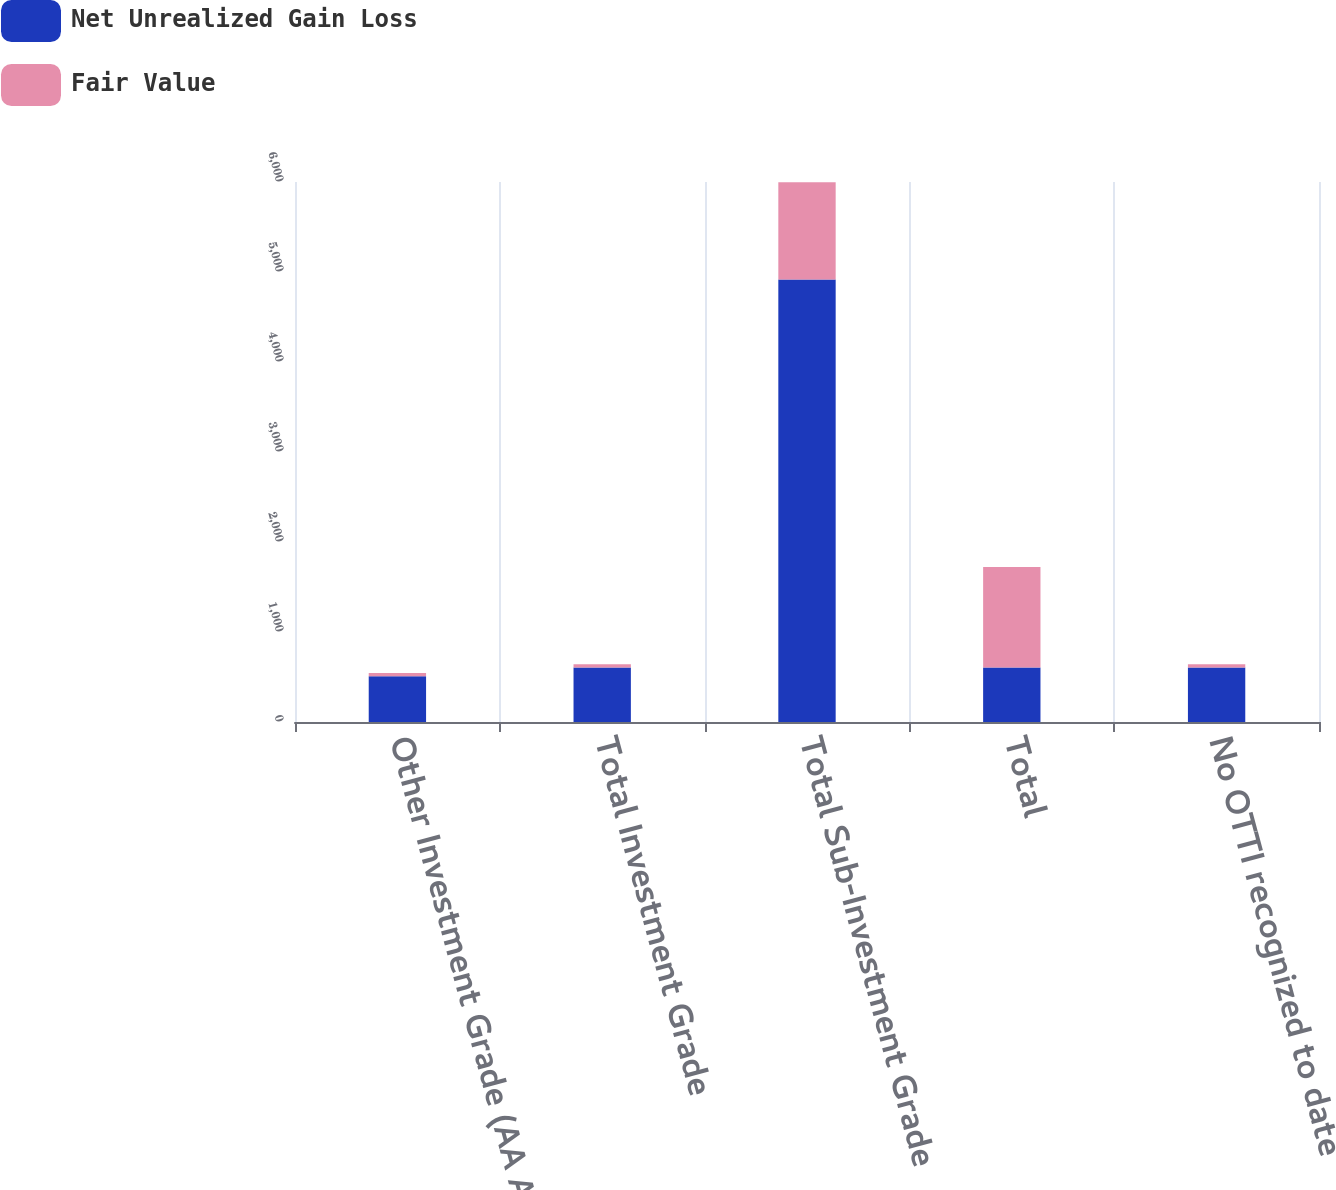Convert chart. <chart><loc_0><loc_0><loc_500><loc_500><stacked_bar_chart><ecel><fcel>Other Investment Grade (AA A<fcel>Total Investment Grade<fcel>Total Sub-Investment Grade<fcel>Total<fcel>No OTTI recognized to date<nl><fcel>Net Unrealized Gain Loss<fcel>509<fcel>606<fcel>4916<fcel>606<fcel>606<nl><fcel>Fair Value<fcel>35<fcel>36<fcel>1080<fcel>1116<fcel>36<nl></chart> 